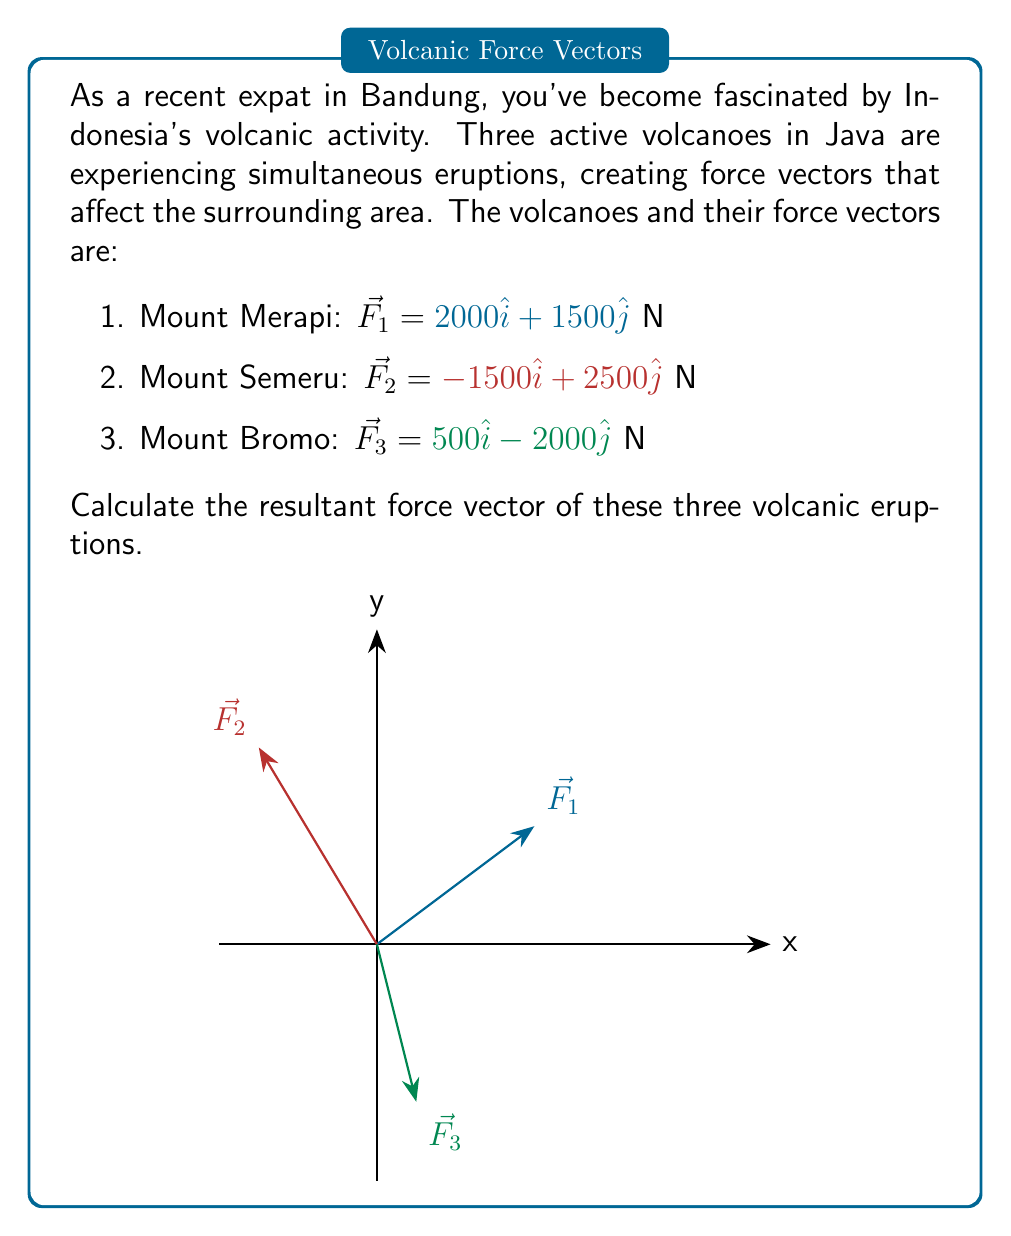Can you answer this question? To find the resultant force vector, we need to add all the individual force vectors together. Let's break this down step-by-step:

1) First, let's recall that vector addition is done component-wise. We'll add all the x-components and all the y-components separately.

2) For the x-components:
   $F_x = F_{1x} + F_{2x} + F_{3x}$
   $F_x = 2000 + (-1500) + 500$
   $F_x = 1000$ N

3) For the y-components:
   $F_y = F_{1y} + F_{2y} + F_{3y}$
   $F_y = 1500 + 2500 + (-2000)$
   $F_y = 2000$ N

4) Now we have the x and y components of the resultant force vector. We can express this as:

   $\vec{F_R} = 1000\hat{i} + 2000\hat{j}$ N

5) If we wanted to find the magnitude of this resultant force, we could use the Pythagorean theorem:

   $|\vec{F_R}| = \sqrt{1000^2 + 2000^2} = \sqrt{5,000,000} = 2236.07$ N

6) And if we wanted the direction, we could find the angle with respect to the positive x-axis:

   $\theta = \tan^{-1}(\frac{2000}{1000}) = 63.43°$

However, the question only asks for the resultant force vector, so we don't need to calculate these last two steps for our final answer.
Answer: $\vec{F_R} = 1000\hat{i} + 2000\hat{j}$ N 